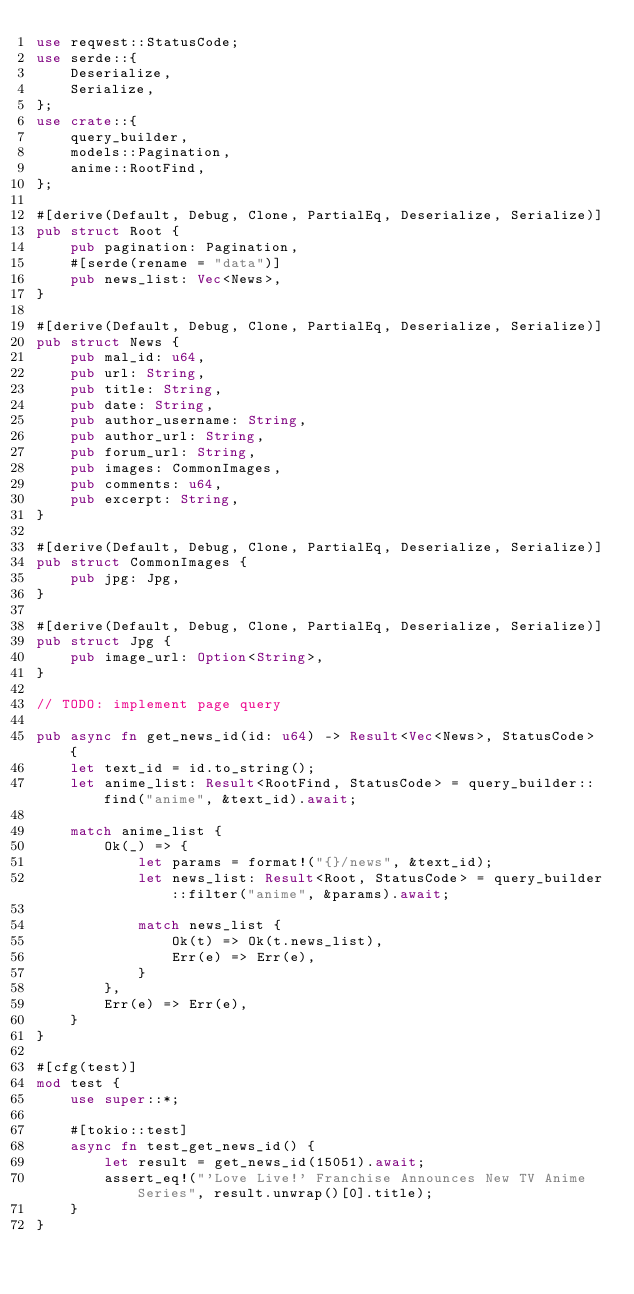<code> <loc_0><loc_0><loc_500><loc_500><_Rust_>use reqwest::StatusCode;
use serde::{
    Deserialize,
    Serialize,
};
use crate::{
    query_builder,
    models::Pagination,
    anime::RootFind,
};

#[derive(Default, Debug, Clone, PartialEq, Deserialize, Serialize)]
pub struct Root {
    pub pagination: Pagination,
    #[serde(rename = "data")]
    pub news_list: Vec<News>,
}

#[derive(Default, Debug, Clone, PartialEq, Deserialize, Serialize)]
pub struct News {
    pub mal_id: u64,
    pub url: String,
    pub title: String,
    pub date: String,
    pub author_username: String,
    pub author_url: String,
    pub forum_url: String,
    pub images: CommonImages,
    pub comments: u64,
    pub excerpt: String,
}

#[derive(Default, Debug, Clone, PartialEq, Deserialize, Serialize)]
pub struct CommonImages {
    pub jpg: Jpg,
}

#[derive(Default, Debug, Clone, PartialEq, Deserialize, Serialize)]
pub struct Jpg {
    pub image_url: Option<String>,
}

// TODO: implement page query

pub async fn get_news_id(id: u64) -> Result<Vec<News>, StatusCode> {
    let text_id = id.to_string();
    let anime_list: Result<RootFind, StatusCode> = query_builder::find("anime", &text_id).await;

    match anime_list {
        Ok(_) => {
            let params = format!("{}/news", &text_id);
            let news_list: Result<Root, StatusCode> = query_builder::filter("anime", &params).await;

            match news_list {
                Ok(t) => Ok(t.news_list),
                Err(e) => Err(e),
            }
        },
        Err(e) => Err(e),
    }
}

#[cfg(test)]
mod test {
    use super::*;

    #[tokio::test]
    async fn test_get_news_id() {
        let result = get_news_id(15051).await;
        assert_eq!("'Love Live!' Franchise Announces New TV Anime Series", result.unwrap()[0].title);
    }
}
</code> 